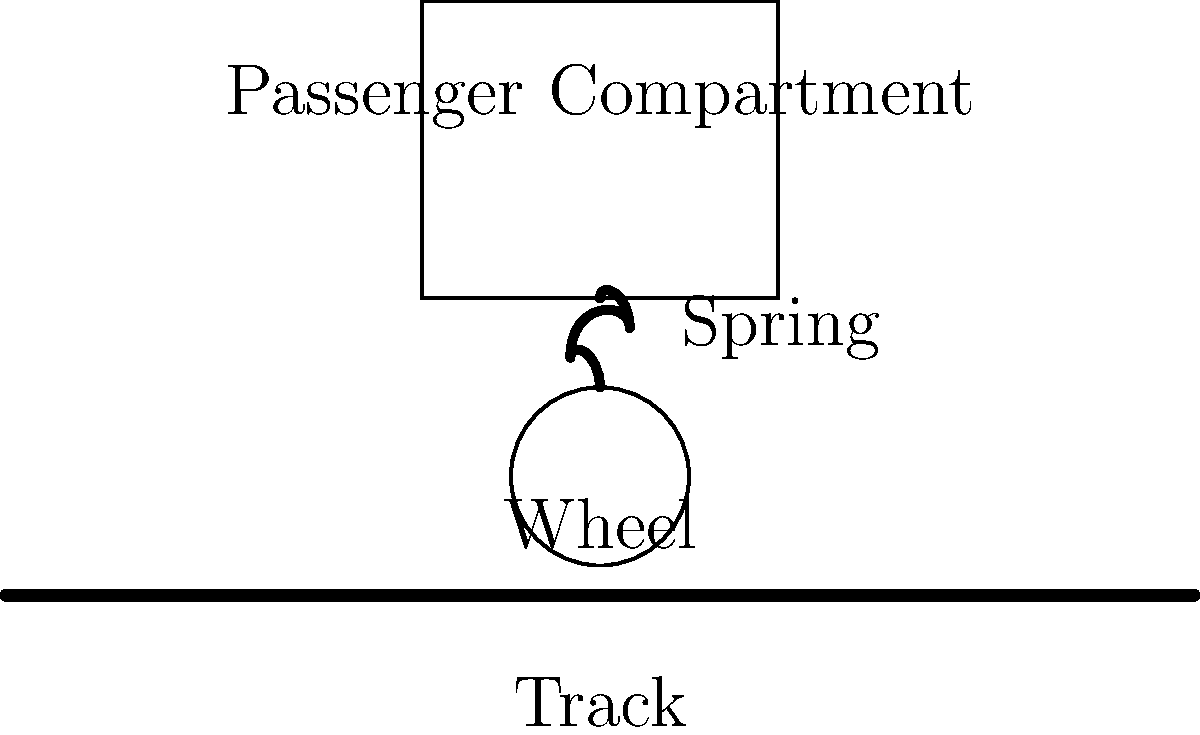In the Basque railway suspension system shown, what type of suspension is most likely used to ensure passenger comfort, especially when navigating the region's hilly terrain? To determine the most suitable suspension system for the Basque railway, we need to consider several factors:

1. Terrain: The Basque region is known for its hilly and varied landscape, which requires a suspension system capable of handling uneven tracks and frequent changes in elevation.

2. Passenger comfort: The system must provide a smooth ride, minimizing vertical and lateral movements transmitted from the track to the passenger compartment.

3. Historical context: As a nostalgic local, you'd remember the system used in your youth, which was likely developed in the mid-20th century.

4. Mechanical simplicity: Railway systems often prioritize reliable, easy-to-maintain designs.

Considering these factors, the most likely suspension system used would be a combination of:

a) Primary suspension: Steel coil springs or rubber elements between the wheelset and the bogie frame.
b) Secondary suspension: Air springs (pneumatic suspension) between the bogie frame and the car body.

This combination offers several advantages:

1. Steel coil springs in the primary suspension provide basic vibration isolation and are simple and reliable.

2. Air springs in the secondary suspension offer:
   - Variable stiffness to adapt to different loads and track conditions
   - Excellent isolation of high-frequency vibrations
   - Ability to maintain a constant ride height regardless of load
   - Good lateral stability, which is crucial for passenger comfort in hilly terrain

3. This system was commonly adopted in many European railways during the mid-20th century, aligning with the nostalgic perspective.

4. The air spring system can be easily adjusted to provide optimal comfort in various track conditions, making it ideal for the diverse Basque landscape.

Therefore, the most likely suspension system used in this Basque railway for ensuring passenger comfort would be a combination of steel coil springs (primary) and air springs (secondary).
Answer: Coil springs (primary) and air springs (secondary) 